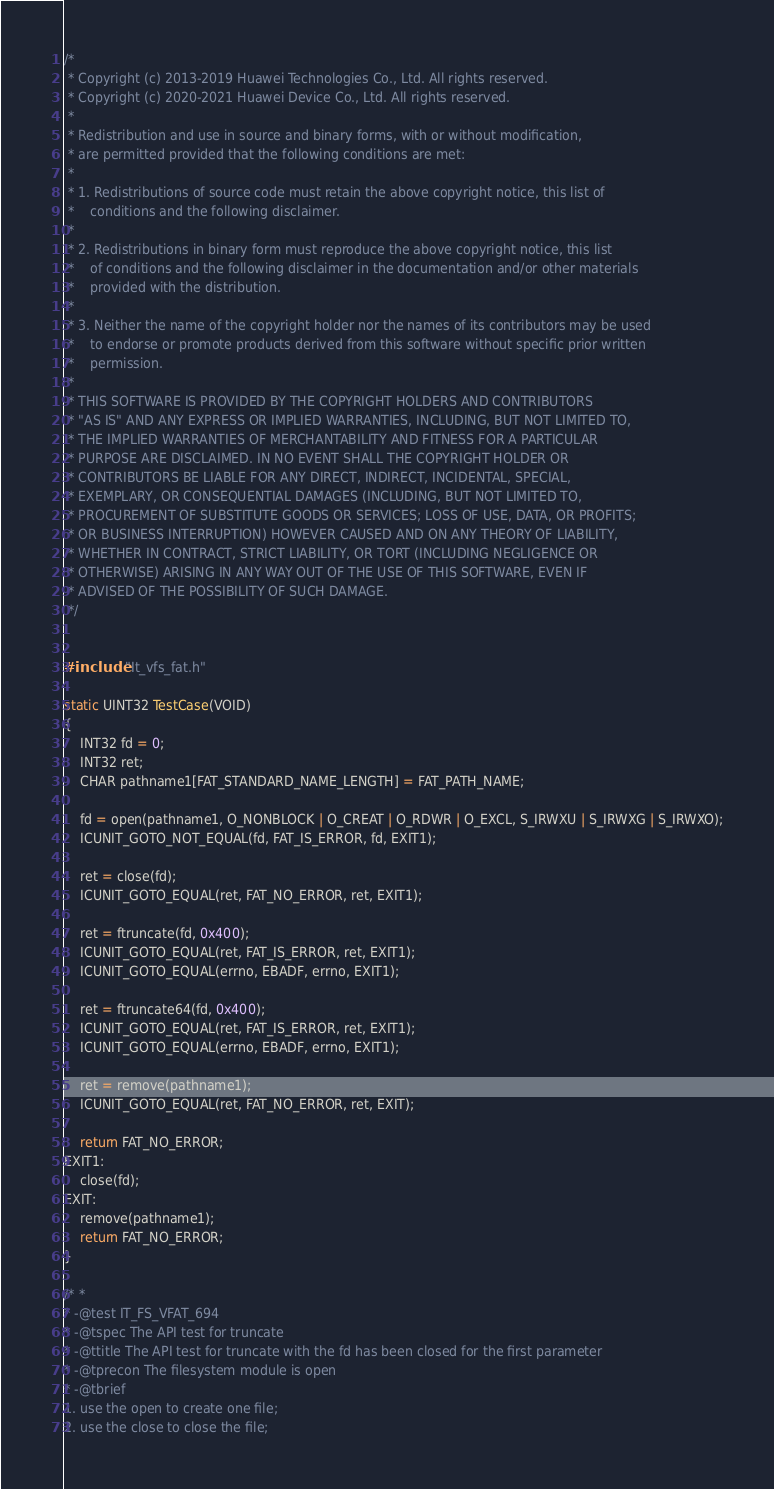<code> <loc_0><loc_0><loc_500><loc_500><_C++_>/*
 * Copyright (c) 2013-2019 Huawei Technologies Co., Ltd. All rights reserved.
 * Copyright (c) 2020-2021 Huawei Device Co., Ltd. All rights reserved.
 *
 * Redistribution and use in source and binary forms, with or without modification,
 * are permitted provided that the following conditions are met:
 *
 * 1. Redistributions of source code must retain the above copyright notice, this list of
 *    conditions and the following disclaimer.
 *
 * 2. Redistributions in binary form must reproduce the above copyright notice, this list
 *    of conditions and the following disclaimer in the documentation and/or other materials
 *    provided with the distribution.
 *
 * 3. Neither the name of the copyright holder nor the names of its contributors may be used
 *    to endorse or promote products derived from this software without specific prior written
 *    permission.
 *
 * THIS SOFTWARE IS PROVIDED BY THE COPYRIGHT HOLDERS AND CONTRIBUTORS
 * "AS IS" AND ANY EXPRESS OR IMPLIED WARRANTIES, INCLUDING, BUT NOT LIMITED TO,
 * THE IMPLIED WARRANTIES OF MERCHANTABILITY AND FITNESS FOR A PARTICULAR
 * PURPOSE ARE DISCLAIMED. IN NO EVENT SHALL THE COPYRIGHT HOLDER OR
 * CONTRIBUTORS BE LIABLE FOR ANY DIRECT, INDIRECT, INCIDENTAL, SPECIAL,
 * EXEMPLARY, OR CONSEQUENTIAL DAMAGES (INCLUDING, BUT NOT LIMITED TO,
 * PROCUREMENT OF SUBSTITUTE GOODS OR SERVICES; LOSS OF USE, DATA, OR PROFITS;
 * OR BUSINESS INTERRUPTION) HOWEVER CAUSED AND ON ANY THEORY OF LIABILITY,
 * WHETHER IN CONTRACT, STRICT LIABILITY, OR TORT (INCLUDING NEGLIGENCE OR
 * OTHERWISE) ARISING IN ANY WAY OUT OF THE USE OF THIS SOFTWARE, EVEN IF
 * ADVISED OF THE POSSIBILITY OF SUCH DAMAGE.
 */


#include "It_vfs_fat.h"

static UINT32 TestCase(VOID)
{
    INT32 fd = 0;
    INT32 ret;
    CHAR pathname1[FAT_STANDARD_NAME_LENGTH] = FAT_PATH_NAME;

    fd = open(pathname1, O_NONBLOCK | O_CREAT | O_RDWR | O_EXCL, S_IRWXU | S_IRWXG | S_IRWXO);
    ICUNIT_GOTO_NOT_EQUAL(fd, FAT_IS_ERROR, fd, EXIT1);

    ret = close(fd);
    ICUNIT_GOTO_EQUAL(ret, FAT_NO_ERROR, ret, EXIT1);

    ret = ftruncate(fd, 0x400);
    ICUNIT_GOTO_EQUAL(ret, FAT_IS_ERROR, ret, EXIT1);
    ICUNIT_GOTO_EQUAL(errno, EBADF, errno, EXIT1);

    ret = ftruncate64(fd, 0x400);
    ICUNIT_GOTO_EQUAL(ret, FAT_IS_ERROR, ret, EXIT1);
    ICUNIT_GOTO_EQUAL(errno, EBADF, errno, EXIT1);

    ret = remove(pathname1);
    ICUNIT_GOTO_EQUAL(ret, FAT_NO_ERROR, ret, EXIT);

    return FAT_NO_ERROR;
EXIT1:
    close(fd);
EXIT:
    remove(pathname1);
    return FAT_NO_ERROR;
}

/* *
* -@test IT_FS_VFAT_694
* -@tspec The API test for truncate
* -@ttitle The API test for truncate with the fd has been closed for the first parameter
* -@tprecon The filesystem module is open
* -@tbrief
1. use the open to create one file;
2. use the close to close the file;</code> 